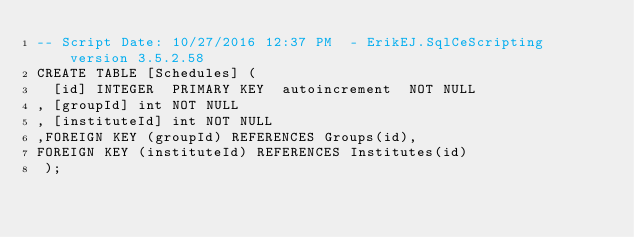Convert code to text. <code><loc_0><loc_0><loc_500><loc_500><_SQL_>-- Script Date: 10/27/2016 12:37 PM  - ErikEJ.SqlCeScripting version 3.5.2.58
CREATE TABLE [Schedules] (
  [id] INTEGER  PRIMARY KEY  autoincrement  NOT NULL
, [groupId] int NOT NULL
, [instituteId] int NOT NULL
,FOREIGN KEY (groupId) REFERENCES Groups(id),
FOREIGN KEY (instituteId) REFERENCES Institutes(id)
 );
</code> 